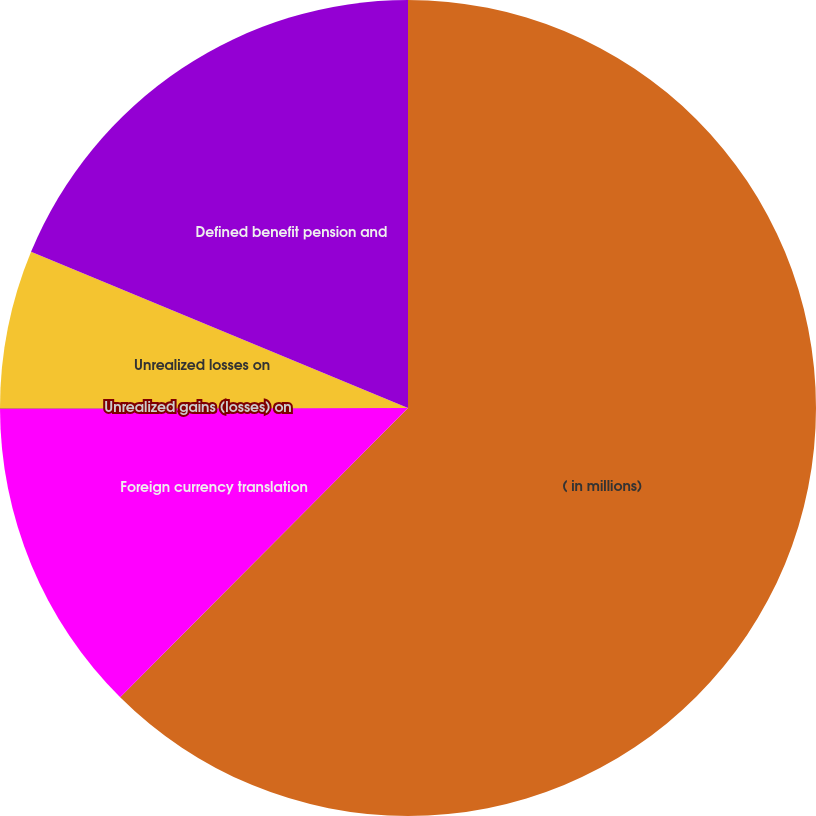Convert chart to OTSL. <chart><loc_0><loc_0><loc_500><loc_500><pie_chart><fcel>( in millions)<fcel>Foreign currency translation<fcel>Unrealized gains (losses) on<fcel>Unrealized losses on<fcel>Defined benefit pension and<nl><fcel>62.47%<fcel>12.51%<fcel>0.02%<fcel>6.26%<fcel>18.75%<nl></chart> 